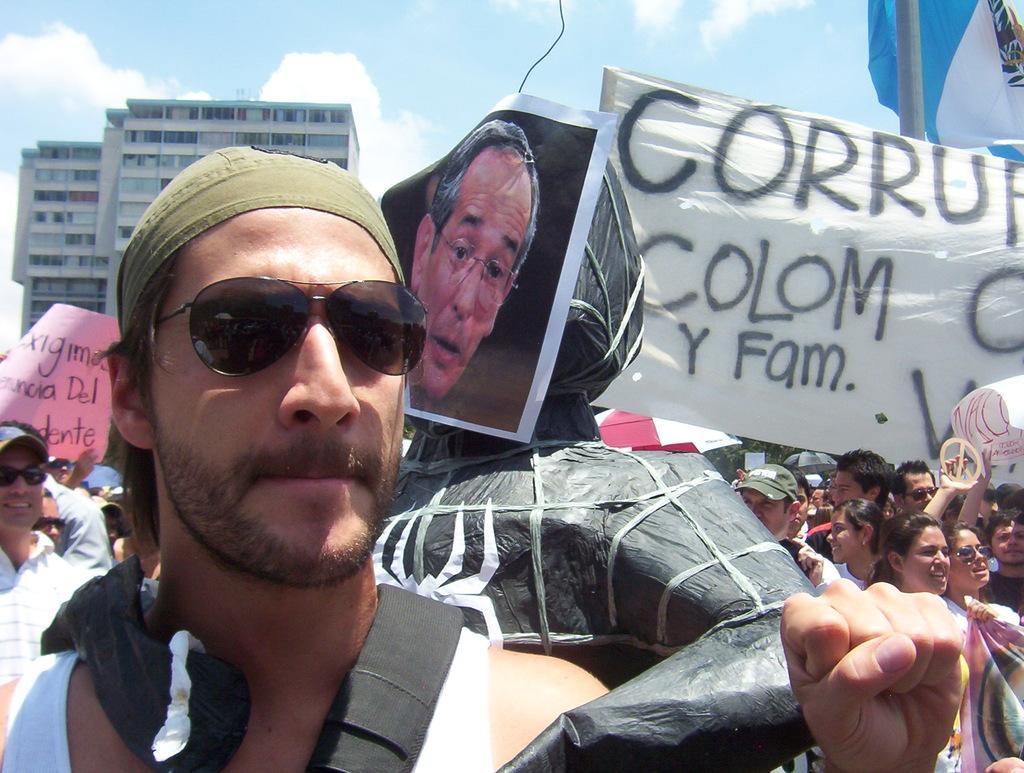Describe this image in one or two sentences. There are group of people standing. Among them few people are building the banners in their hands. This looks like a pole. I can see the buildings with the windows. These are the clouds in the sky. 